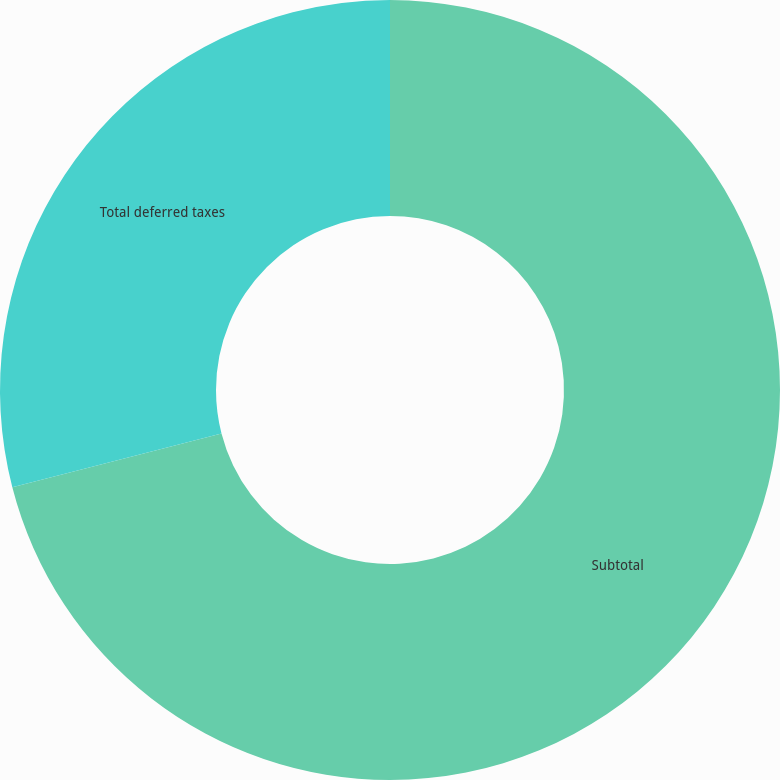Convert chart. <chart><loc_0><loc_0><loc_500><loc_500><pie_chart><fcel>Subtotal<fcel>Total deferred taxes<nl><fcel>70.99%<fcel>29.01%<nl></chart> 